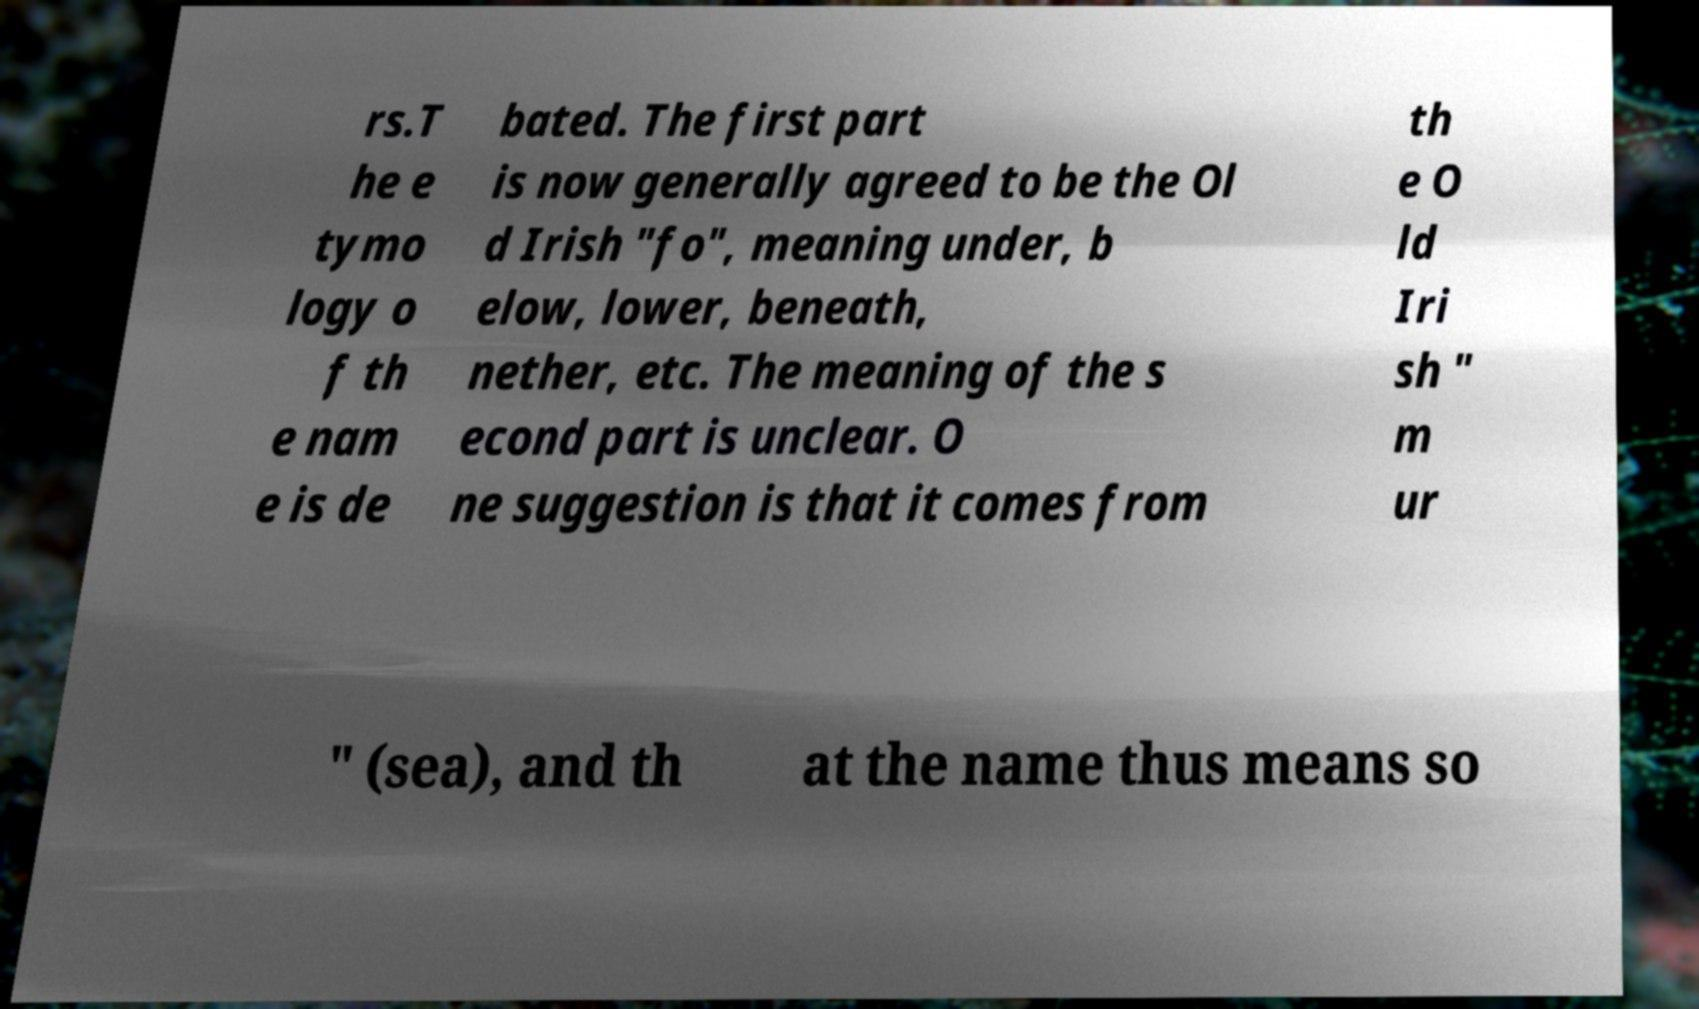What messages or text are displayed in this image? I need them in a readable, typed format. rs.T he e tymo logy o f th e nam e is de bated. The first part is now generally agreed to be the Ol d Irish "fo", meaning under, b elow, lower, beneath, nether, etc. The meaning of the s econd part is unclear. O ne suggestion is that it comes from th e O ld Iri sh " m ur " (sea), and th at the name thus means so 